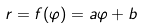<formula> <loc_0><loc_0><loc_500><loc_500>r = f ( \varphi ) = a \varphi + b</formula> 